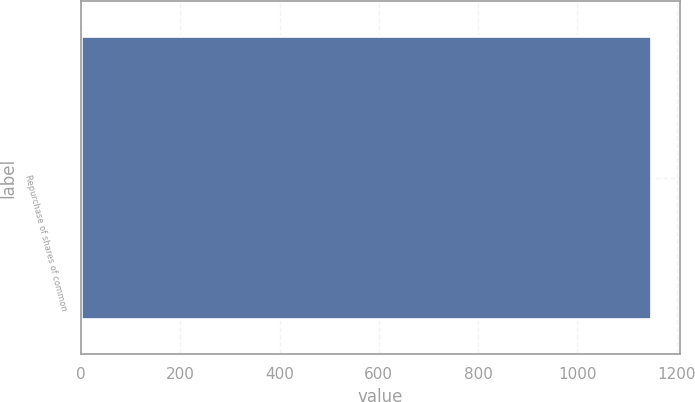Convert chart. <chart><loc_0><loc_0><loc_500><loc_500><bar_chart><fcel>Repurchase of shares of common<nl><fcel>1149<nl></chart> 